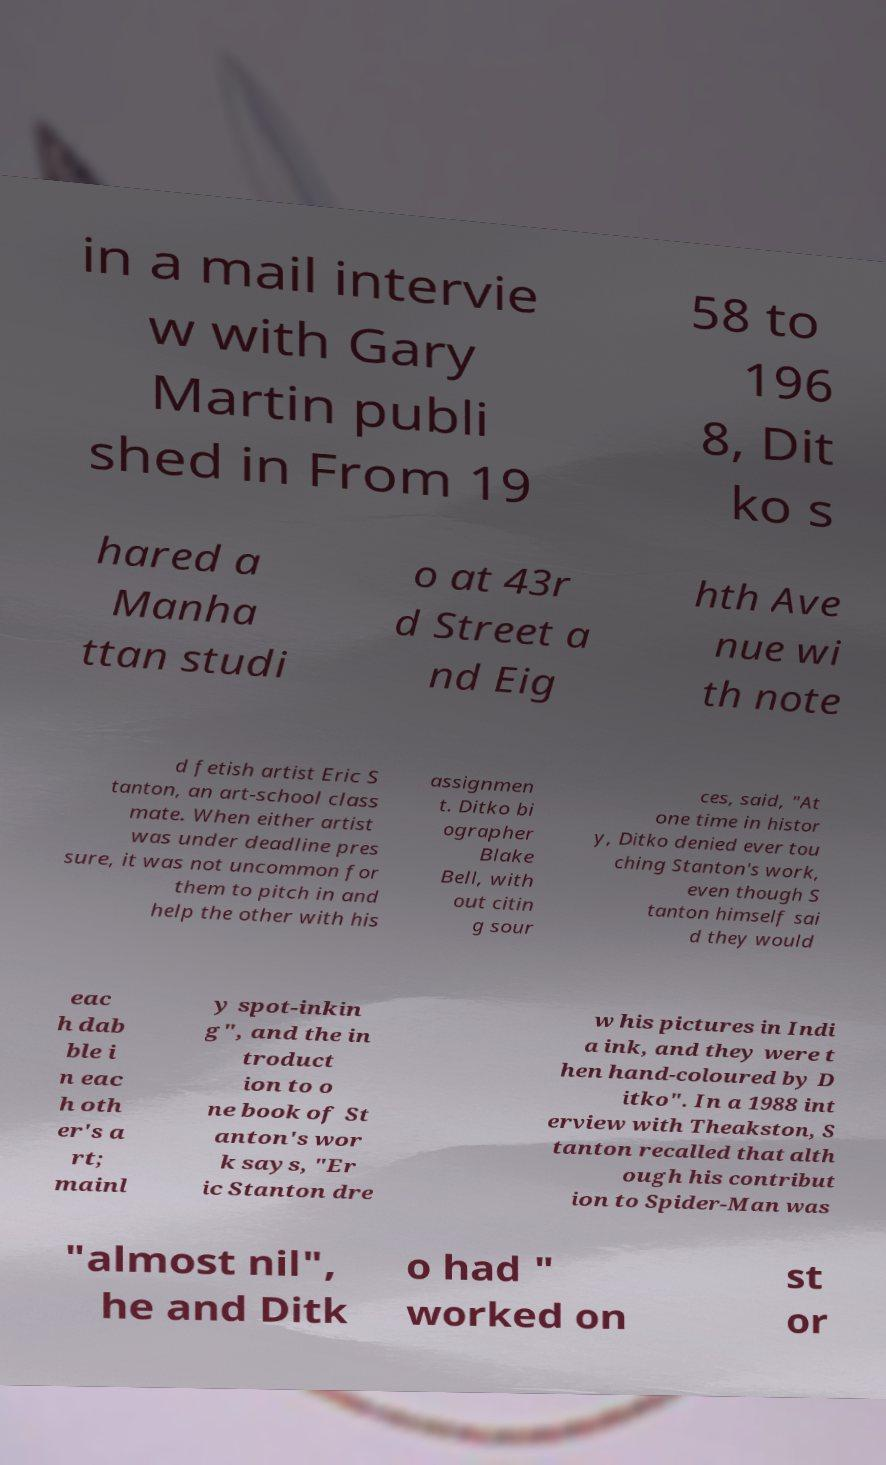Could you extract and type out the text from this image? in a mail intervie w with Gary Martin publi shed in From 19 58 to 196 8, Dit ko s hared a Manha ttan studi o at 43r d Street a nd Eig hth Ave nue wi th note d fetish artist Eric S tanton, an art-school class mate. When either artist was under deadline pres sure, it was not uncommon for them to pitch in and help the other with his assignmen t. Ditko bi ographer Blake Bell, with out citin g sour ces, said, "At one time in histor y, Ditko denied ever tou ching Stanton's work, even though S tanton himself sai d they would eac h dab ble i n eac h oth er's a rt; mainl y spot-inkin g", and the in troduct ion to o ne book of St anton's wor k says, "Er ic Stanton dre w his pictures in Indi a ink, and they were t hen hand-coloured by D itko". In a 1988 int erview with Theakston, S tanton recalled that alth ough his contribut ion to Spider-Man was "almost nil", he and Ditk o had " worked on st or 